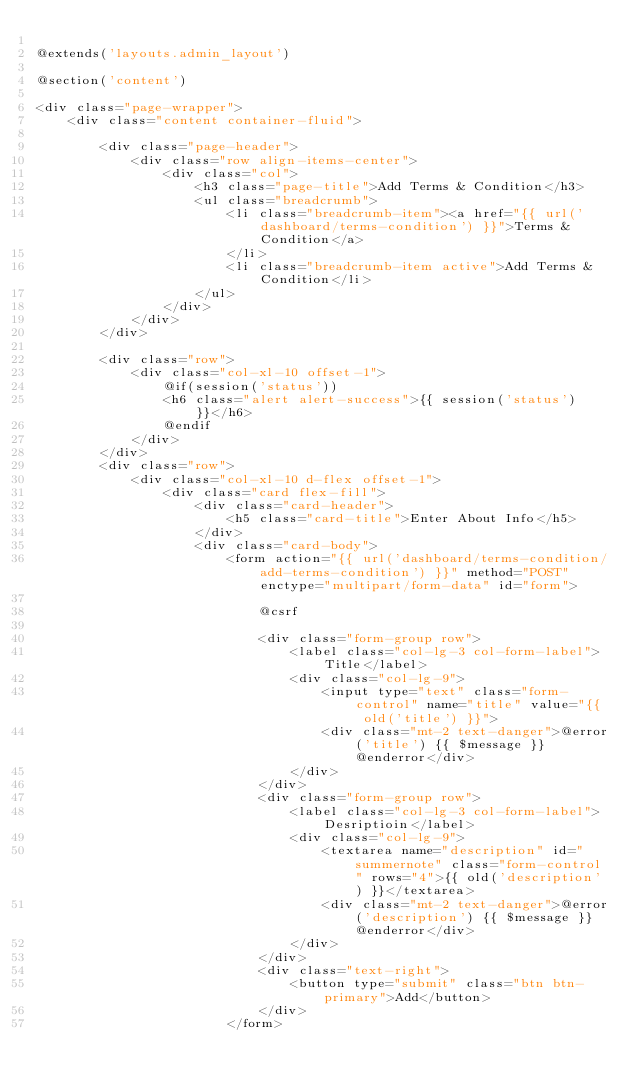<code> <loc_0><loc_0><loc_500><loc_500><_PHP_>
@extends('layouts.admin_layout')

@section('content')

<div class="page-wrapper">
	<div class="content container-fluid">

		<div class="page-header">
			<div class="row align-items-center">
				<div class="col">
					<h3 class="page-title">Add Terms & Condition</h3>
					<ul class="breadcrumb">
						<li class="breadcrumb-item"><a href="{{ url('dashboard/terms-condition') }}">Terms & Condition</a>
						</li>
						<li class="breadcrumb-item active">Add Terms & Condition</li>
					</ul>
				</div>
			</div>
		</div>

		<div class="row">
			<div class="col-xl-10 offset-1">
				@if(session('status'))
				<h6 class="alert alert-success">{{ session('status') }}</h6>
				@endif
			</div>
		</div>
		<div class="row">
			<div class="col-xl-10 d-flex offset-1">
				<div class="card flex-fill">
					<div class="card-header">
						<h5 class="card-title">Enter About Info</h5>
					</div>
					<div class="card-body">
						<form action="{{ url('dashboard/terms-condition/add-terms-condition') }}" method="POST" enctype="multipart/form-data" id="form">

							@csrf

							<div class="form-group row">
								<label class="col-lg-3 col-form-label">Title</label>
								<div class="col-lg-9">
									<input type="text" class="form-control" name="title" value="{{ old('title') }}">
									<div class="mt-2 text-danger">@error('title') {{ $message }} @enderror</div>
								</div>
							</div>
							<div class="form-group row">
								<label class="col-lg-3 col-form-label">Desriptioin</label>
								<div class="col-lg-9">
									<textarea name="description" id="summernote" class="form-control" rows="4">{{ old('description') }}</textarea>
									<div class="mt-2 text-danger">@error('description') {{ $message }} @enderror</div>
								</div>
							</div>
							<div class="text-right">
								<button type="submit" class="btn btn-primary">Add</button>
							</div>
						</form></code> 